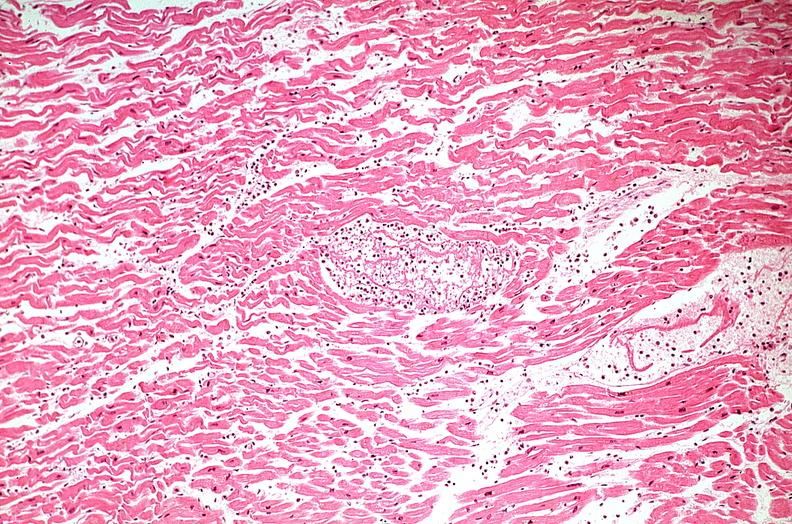where is this from?
Answer the question using a single word or phrase. Heart 